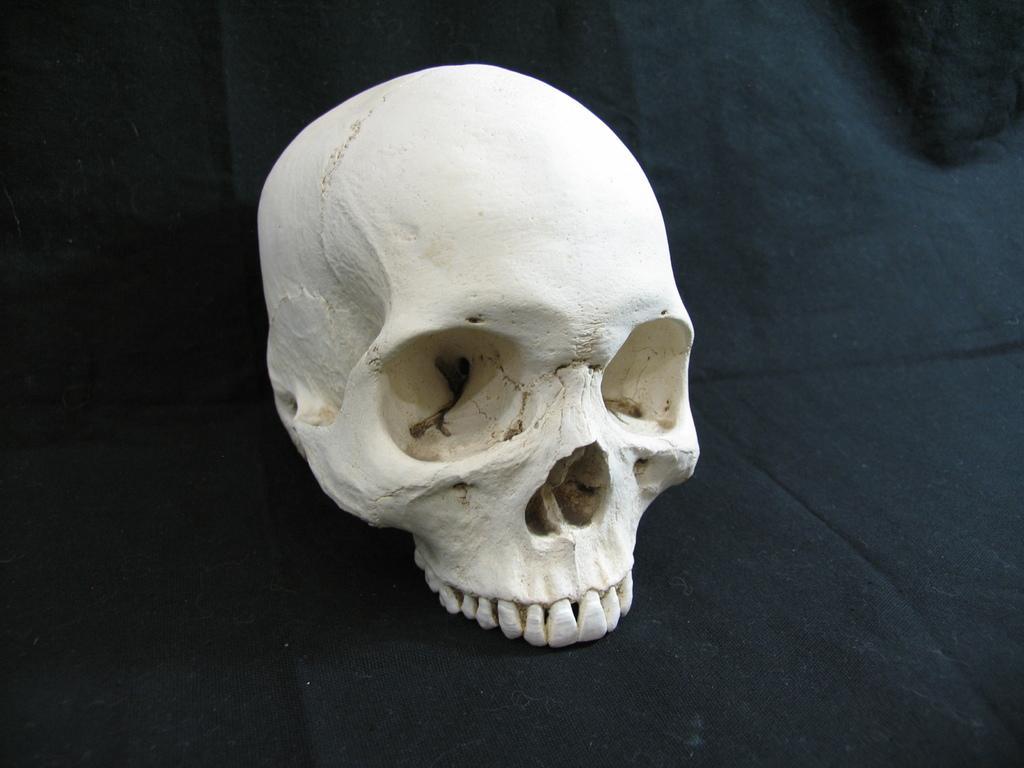How would you summarize this image in a sentence or two? As we can see in the image there is white color human skeleton head on black color cloth. 